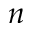<formula> <loc_0><loc_0><loc_500><loc_500>n</formula> 